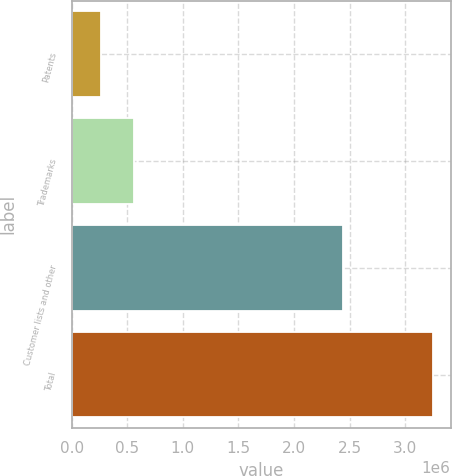Convert chart. <chart><loc_0><loc_0><loc_500><loc_500><bar_chart><fcel>Patents<fcel>Trademarks<fcel>Customer lists and other<fcel>Total<nl><fcel>265644<fcel>563447<fcel>2.43546e+06<fcel>3.24368e+06<nl></chart> 